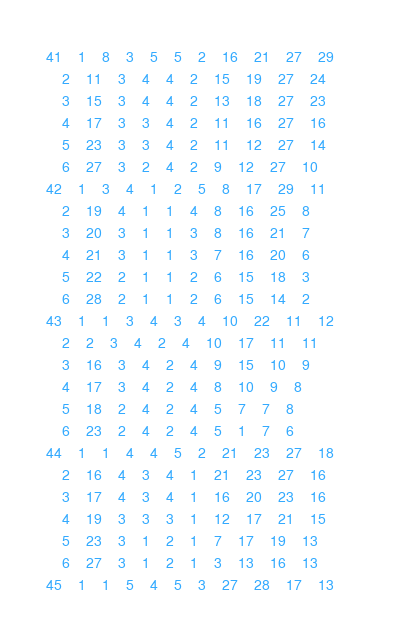<code> <loc_0><loc_0><loc_500><loc_500><_ObjectiveC_>41	1	8	3	5	5	2	16	21	27	29	
	2	11	3	4	4	2	15	19	27	24	
	3	15	3	4	4	2	13	18	27	23	
	4	17	3	3	4	2	11	16	27	16	
	5	23	3	3	4	2	11	12	27	14	
	6	27	3	2	4	2	9	12	27	10	
42	1	3	4	1	2	5	8	17	29	11	
	2	19	4	1	1	4	8	16	25	8	
	3	20	3	1	1	3	8	16	21	7	
	4	21	3	1	1	3	7	16	20	6	
	5	22	2	1	1	2	6	15	18	3	
	6	28	2	1	1	2	6	15	14	2	
43	1	1	3	4	3	4	10	22	11	12	
	2	2	3	4	2	4	10	17	11	11	
	3	16	3	4	2	4	9	15	10	9	
	4	17	3	4	2	4	8	10	9	8	
	5	18	2	4	2	4	5	7	7	8	
	6	23	2	4	2	4	5	1	7	6	
44	1	1	4	4	5	2	21	23	27	18	
	2	16	4	3	4	1	21	23	27	16	
	3	17	4	3	4	1	16	20	23	16	
	4	19	3	3	3	1	12	17	21	15	
	5	23	3	1	2	1	7	17	19	13	
	6	27	3	1	2	1	3	13	16	13	
45	1	1	5	4	5	3	27	28	17	13	</code> 